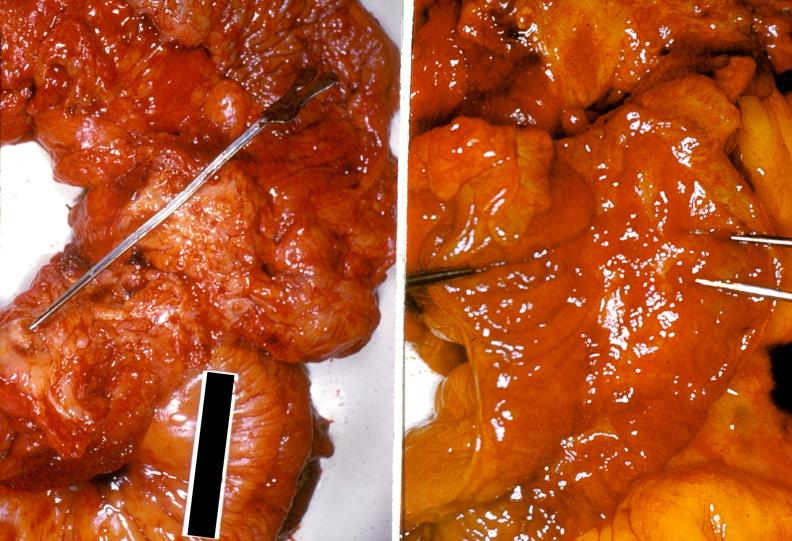what is present?
Answer the question using a single word or phrase. Gastrointestinal 